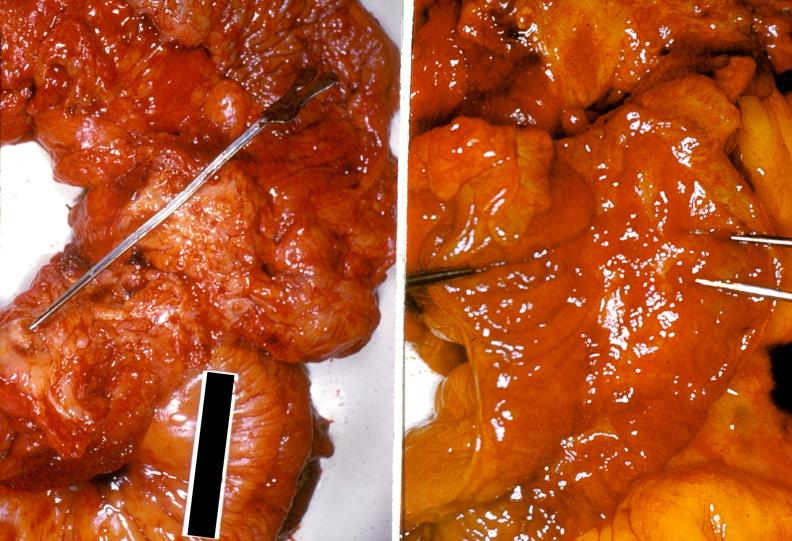what is present?
Answer the question using a single word or phrase. Gastrointestinal 